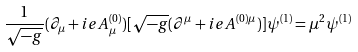<formula> <loc_0><loc_0><loc_500><loc_500>\frac { 1 } { \sqrt { - g } } ( \partial _ { \mu } + i e A ^ { ( 0 ) } _ { \mu } ) [ \sqrt { - g } ( \partial ^ { \mu } + i e A ^ { ( 0 ) \mu } ) ] \psi ^ { ( 1 ) } = \mu ^ { 2 } \psi ^ { ( 1 ) }</formula> 